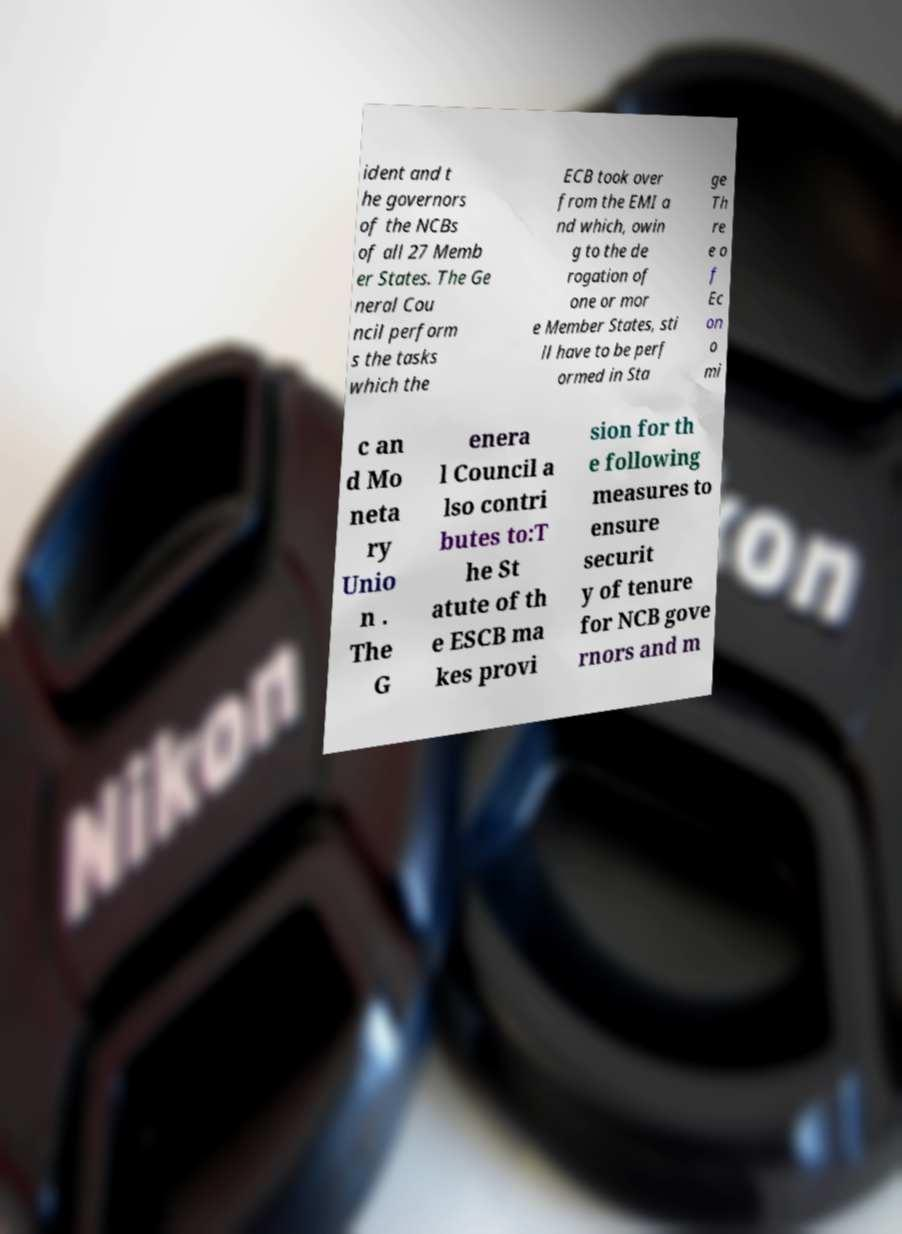Could you assist in decoding the text presented in this image and type it out clearly? ident and t he governors of the NCBs of all 27 Memb er States. The Ge neral Cou ncil perform s the tasks which the ECB took over from the EMI a nd which, owin g to the de rogation of one or mor e Member States, sti ll have to be perf ormed in Sta ge Th re e o f Ec on o mi c an d Mo neta ry Unio n . The G enera l Council a lso contri butes to:T he St atute of th e ESCB ma kes provi sion for th e following measures to ensure securit y of tenure for NCB gove rnors and m 